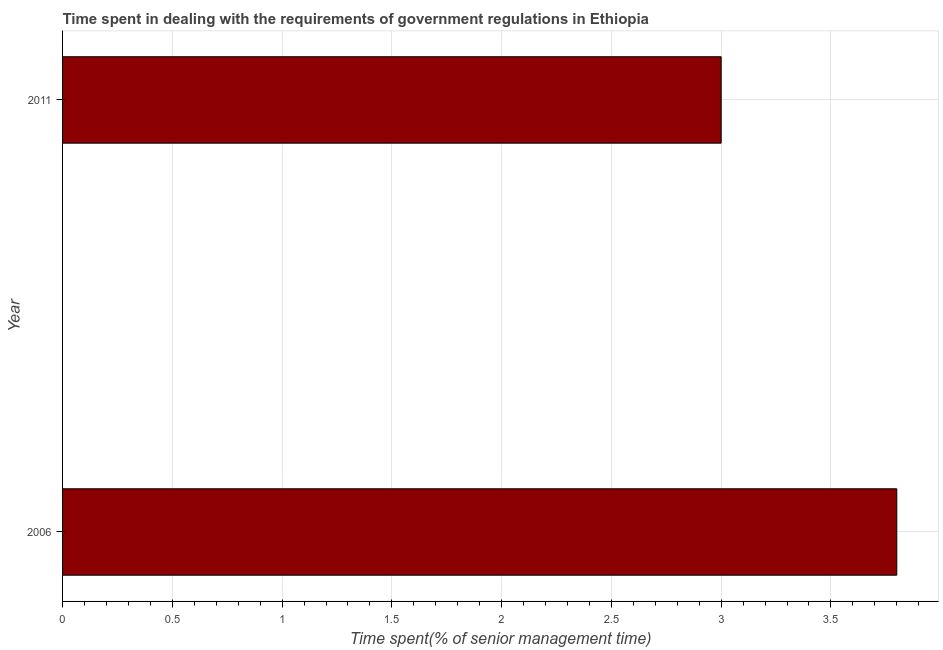Does the graph contain any zero values?
Ensure brevity in your answer.  No. What is the title of the graph?
Your answer should be very brief. Time spent in dealing with the requirements of government regulations in Ethiopia. What is the label or title of the X-axis?
Offer a very short reply. Time spent(% of senior management time). Across all years, what is the maximum time spent in dealing with government regulations?
Offer a terse response. 3.8. What is the sum of the time spent in dealing with government regulations?
Your answer should be compact. 6.8. What is the difference between the time spent in dealing with government regulations in 2006 and 2011?
Offer a very short reply. 0.8. What is the average time spent in dealing with government regulations per year?
Your answer should be very brief. 3.4. In how many years, is the time spent in dealing with government regulations greater than 0.5 %?
Provide a short and direct response. 2. Do a majority of the years between 2006 and 2011 (inclusive) have time spent in dealing with government regulations greater than 0.8 %?
Ensure brevity in your answer.  Yes. What is the ratio of the time spent in dealing with government regulations in 2006 to that in 2011?
Give a very brief answer. 1.27. How many bars are there?
Give a very brief answer. 2. Are all the bars in the graph horizontal?
Your response must be concise. Yes. What is the difference between two consecutive major ticks on the X-axis?
Your answer should be compact. 0.5. What is the difference between the Time spent(% of senior management time) in 2006 and 2011?
Ensure brevity in your answer.  0.8. What is the ratio of the Time spent(% of senior management time) in 2006 to that in 2011?
Your answer should be compact. 1.27. 